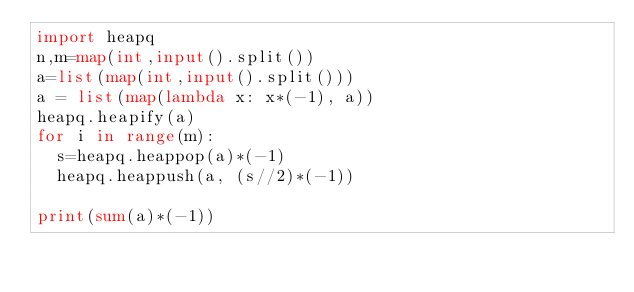<code> <loc_0><loc_0><loc_500><loc_500><_Python_>import heapq
n,m=map(int,input().split())
a=list(map(int,input().split()))
a = list(map(lambda x: x*(-1), a))
heapq.heapify(a)
for i in range(m):
  s=heapq.heappop(a)*(-1)
  heapq.heappush(a, (s//2)*(-1))

print(sum(a)*(-1))</code> 